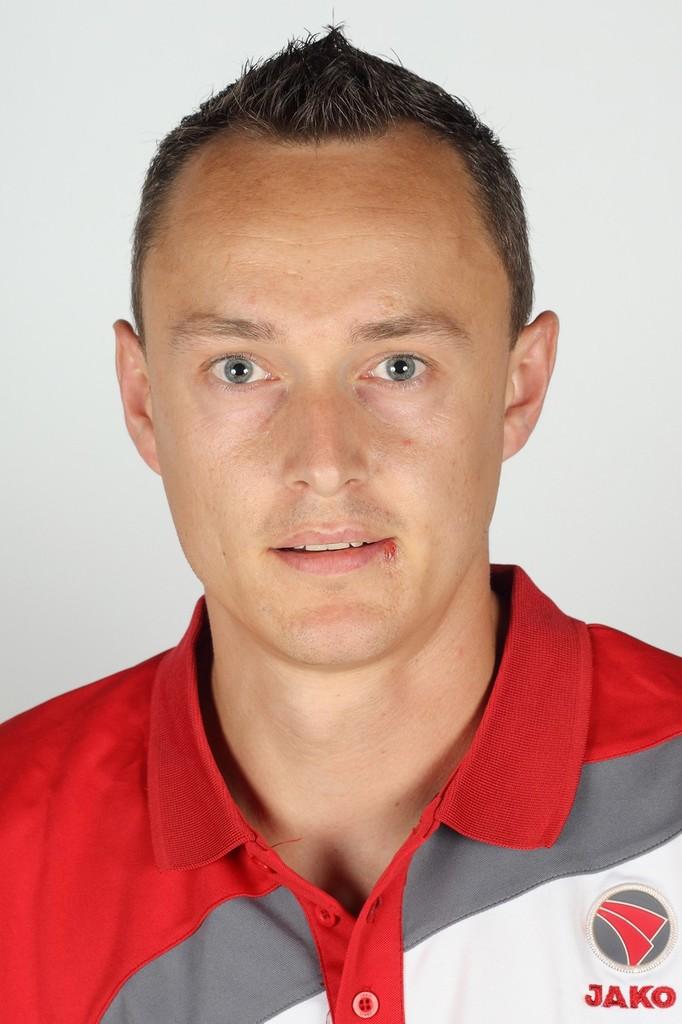What brand is on this shirt?
Your answer should be compact. Jako. 